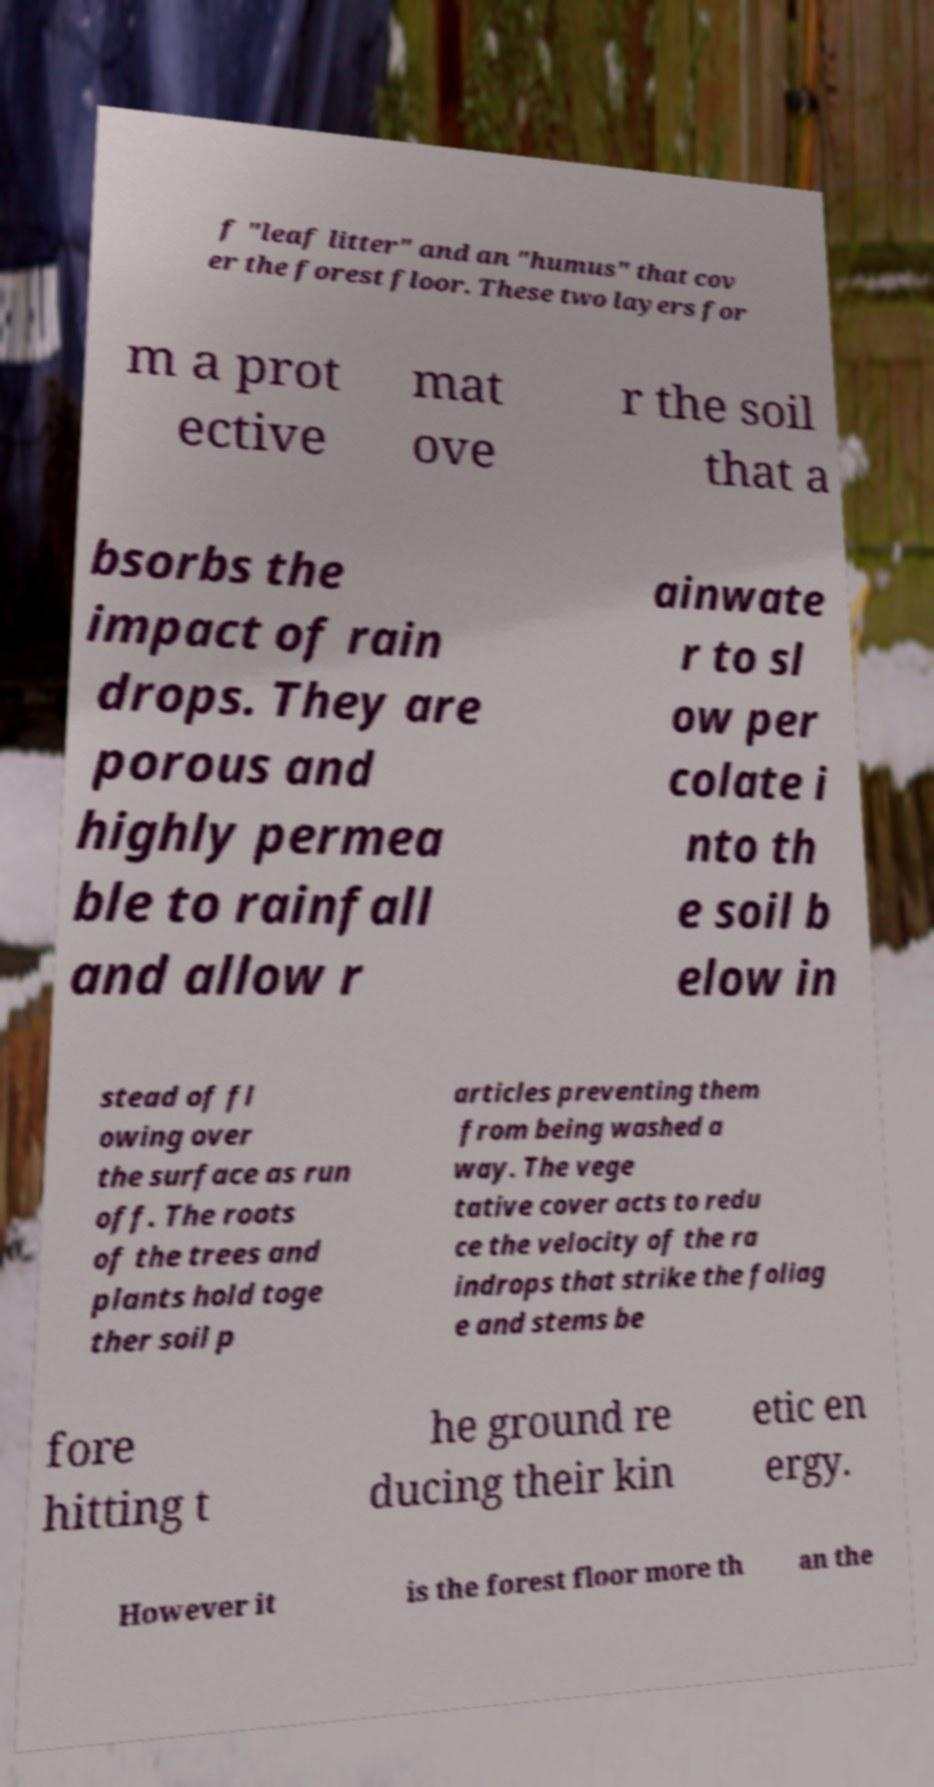Could you assist in decoding the text presented in this image and type it out clearly? f "leaf litter" and an "humus" that cov er the forest floor. These two layers for m a prot ective mat ove r the soil that a bsorbs the impact of rain drops. They are porous and highly permea ble to rainfall and allow r ainwate r to sl ow per colate i nto th e soil b elow in stead of fl owing over the surface as run off. The roots of the trees and plants hold toge ther soil p articles preventing them from being washed a way. The vege tative cover acts to redu ce the velocity of the ra indrops that strike the foliag e and stems be fore hitting t he ground re ducing their kin etic en ergy. However it is the forest floor more th an the 